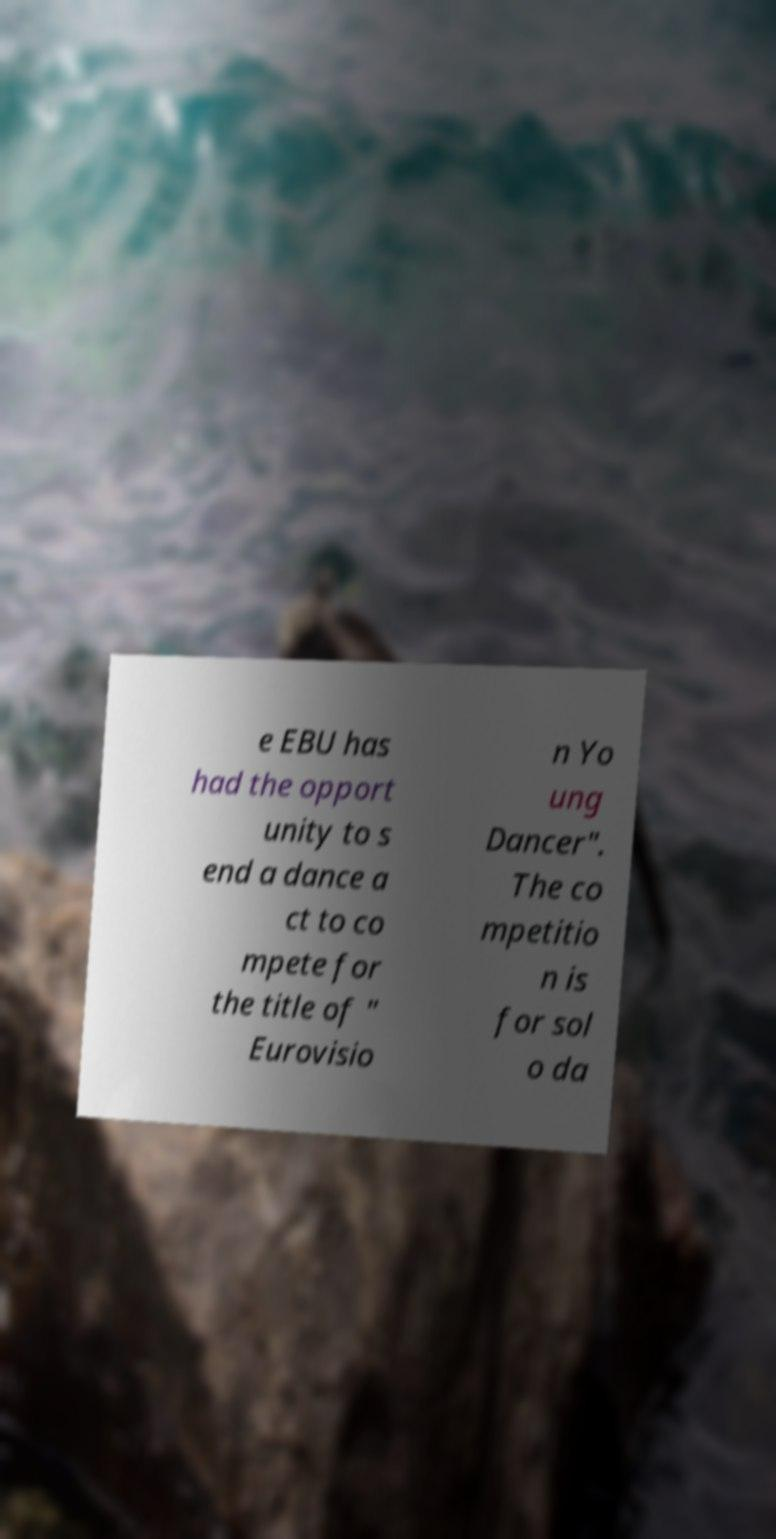There's text embedded in this image that I need extracted. Can you transcribe it verbatim? e EBU has had the opport unity to s end a dance a ct to co mpete for the title of " Eurovisio n Yo ung Dancer". The co mpetitio n is for sol o da 